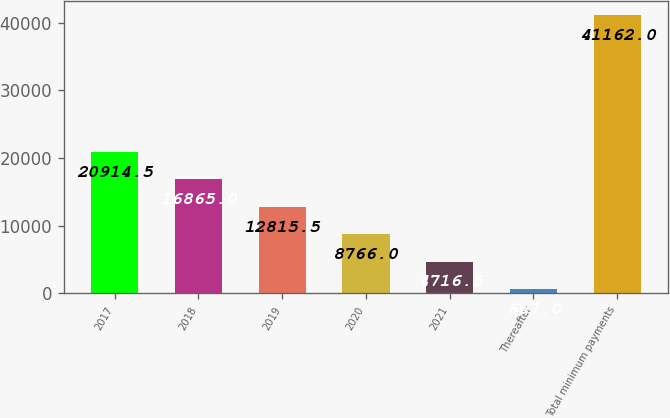Convert chart. <chart><loc_0><loc_0><loc_500><loc_500><bar_chart><fcel>2017<fcel>2018<fcel>2019<fcel>2020<fcel>2021<fcel>Thereafter<fcel>Total minimum payments<nl><fcel>20914.5<fcel>16865<fcel>12815.5<fcel>8766<fcel>4716.5<fcel>667<fcel>41162<nl></chart> 